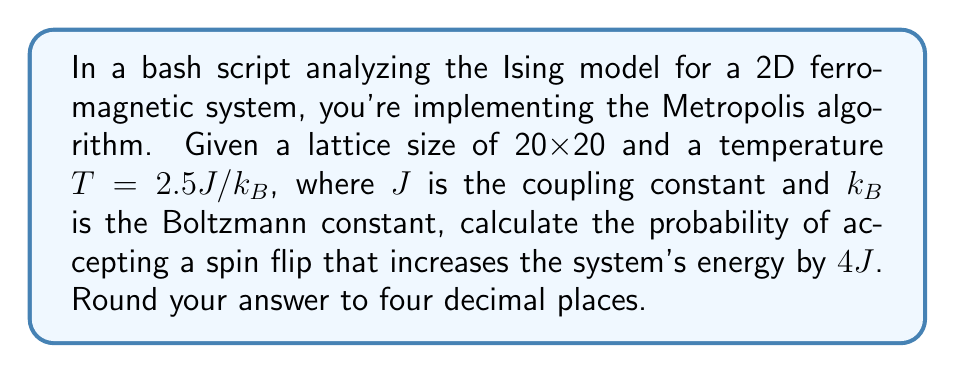Could you help me with this problem? Let's approach this step-by-step:

1) In the Metropolis algorithm for the Ising model, the probability of accepting a spin flip is given by:

   $$P(\Delta E) = \min(1, e^{-\Delta E / (k_B T)})$$

   where $\Delta E$ is the change in energy.

2) We're given that $\Delta E = 4J$ and $T = 2.5J/k_B$.

3) Substituting these values into the equation:

   $$P(4J) = \min(1, e^{-4J / (k_B (2.5J/k_B))})$$

4) Simplify the fraction in the exponent:

   $$P(4J) = \min(1, e^{-4J / (2.5J)}) = \min(1, e^{-1.6})$$

5) Calculate $e^{-1.6}$:

   $$e^{-1.6} \approx 0.2019$$

6) Since $0.2019 < 1$, this is our final probability.

7) Rounding to four decimal places:

   $$P(4J) \approx 0.2019$$
Answer: 0.2019 